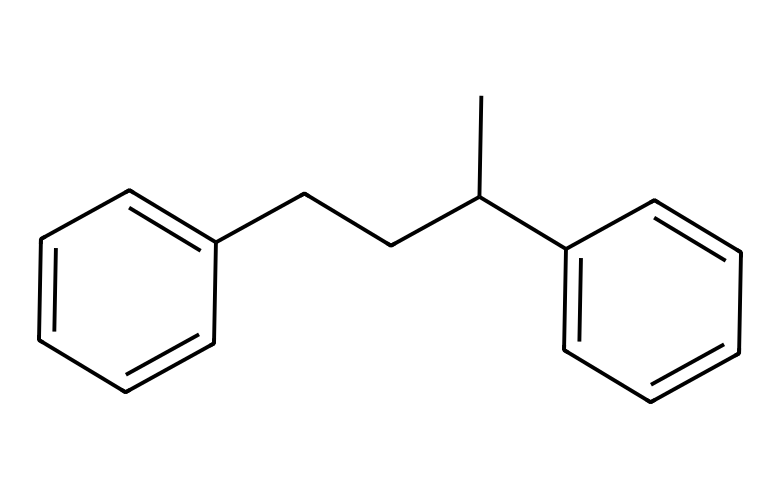How many carbon atoms are present in this structure? By analyzing the SMILES representation, we can count the number of carbon atoms present. The structure consists of multiple branching and cyclic carbon atoms; specifically, there are 16 carbon atoms in total.
Answer: 16 What is the primary functional group present in this chemical? The structure mainly contains aromatic rings, which are indicative of phenyl groups. Polystyrene is derived from the polymerization of styrene, which contains a vinyl group. Thus, the primary functional group is the phenyl group.
Answer: phenyl How many double bonds are present in the structure? One can identify the presence of double bonds by looking at the connections between carbon atoms. The aromatic rings in the structure inherently contain alternating double bonds. There are 4 double bonds in total within the structure, resulting from the two benzene rings.
Answer: 4 Which polymer does this structure represent? The given structure belongs to polystyrene, which is derived from the monomer styrene. The polymerization of styrene under certain conditions yields the long-chain structure exhibited in the representation.
Answer: polystyrene What type of material is this compound primarily used for? Polystyrene is primarily known for its use in packaging materials, especially in the context of protecting fragile items such as artwork during shipping.
Answer: packaging materials 